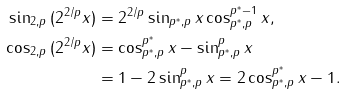Convert formula to latex. <formula><loc_0><loc_0><loc_500><loc_500>\sin _ { 2 , p } { ( 2 ^ { 2 / p } x ) } & = 2 ^ { 2 / p } \sin _ { p ^ { * } , p } { x } \cos _ { p ^ { * } , p } ^ { p ^ { * } - 1 } { x } , \\ \cos _ { 2 , p } { ( 2 ^ { 2 / p } x ) } & = \cos _ { p ^ { * } , p } ^ { p ^ { * } } { x } - \sin _ { p ^ { * } , p } ^ { p } { x } \\ & = 1 - 2 \sin _ { p ^ { * } , p } ^ { p } { x } = 2 \cos _ { p ^ { * } , p } ^ { p ^ { * } } { x } - 1 .</formula> 